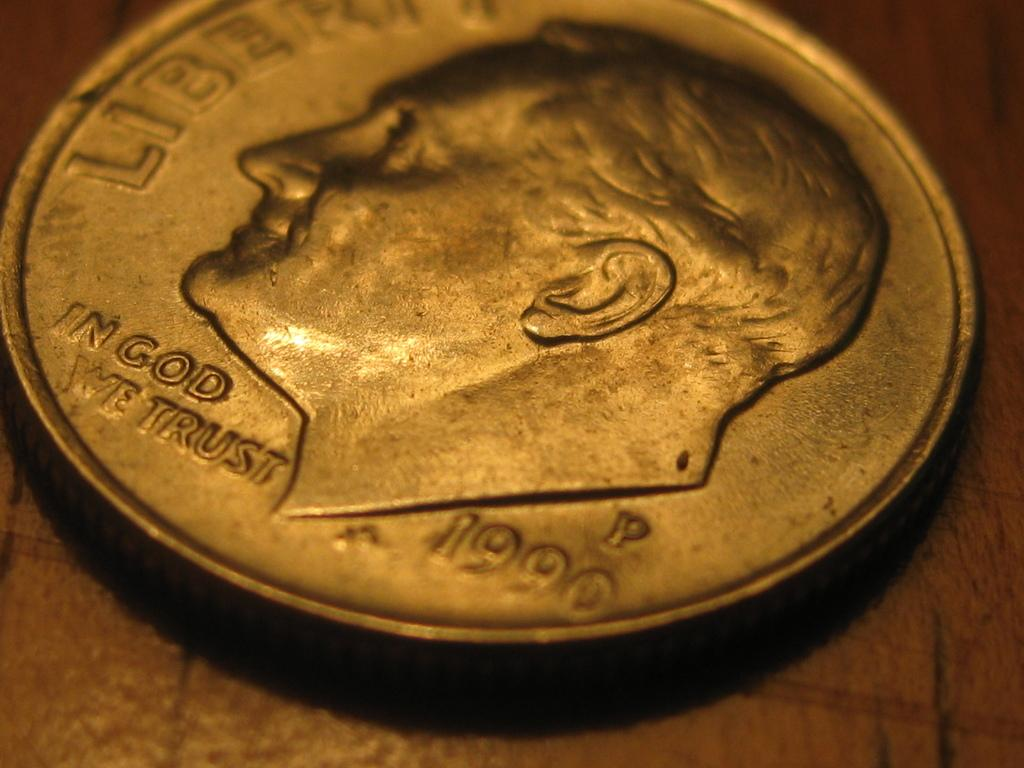<image>
Relay a brief, clear account of the picture shown. Roosevelt golden color coin from the year of 1990 